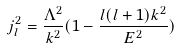Convert formula to latex. <formula><loc_0><loc_0><loc_500><loc_500>j _ { l } ^ { 2 } = \frac { \Lambda ^ { 2 } } { k ^ { 2 } } ( 1 - \frac { l ( l + 1 ) k ^ { 2 } } { E ^ { 2 } } )</formula> 